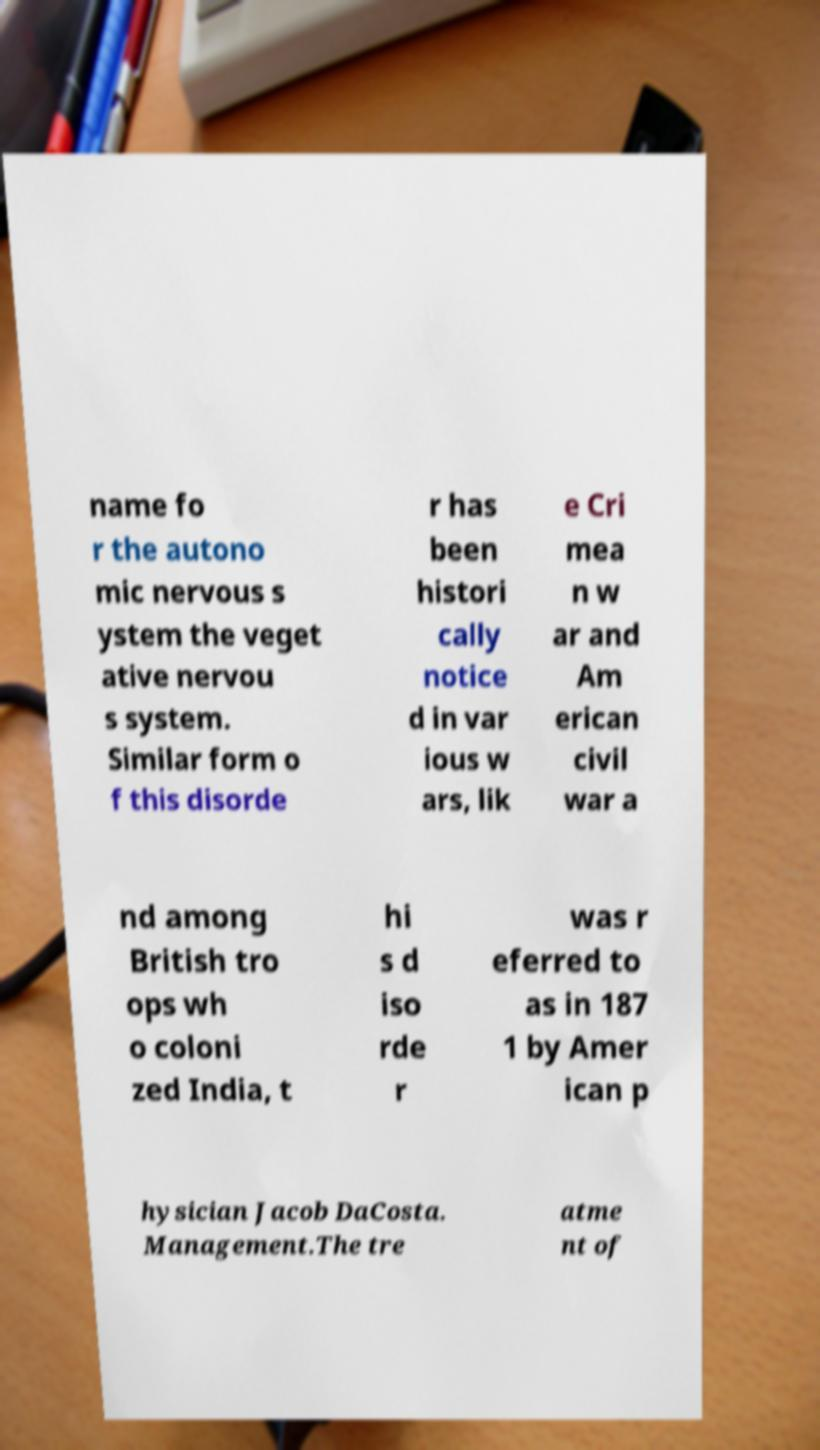For documentation purposes, I need the text within this image transcribed. Could you provide that? name fo r the autono mic nervous s ystem the veget ative nervou s system. Similar form o f this disorde r has been histori cally notice d in var ious w ars, lik e Cri mea n w ar and Am erican civil war a nd among British tro ops wh o coloni zed India, t hi s d iso rde r was r eferred to as in 187 1 by Amer ican p hysician Jacob DaCosta. Management.The tre atme nt of 